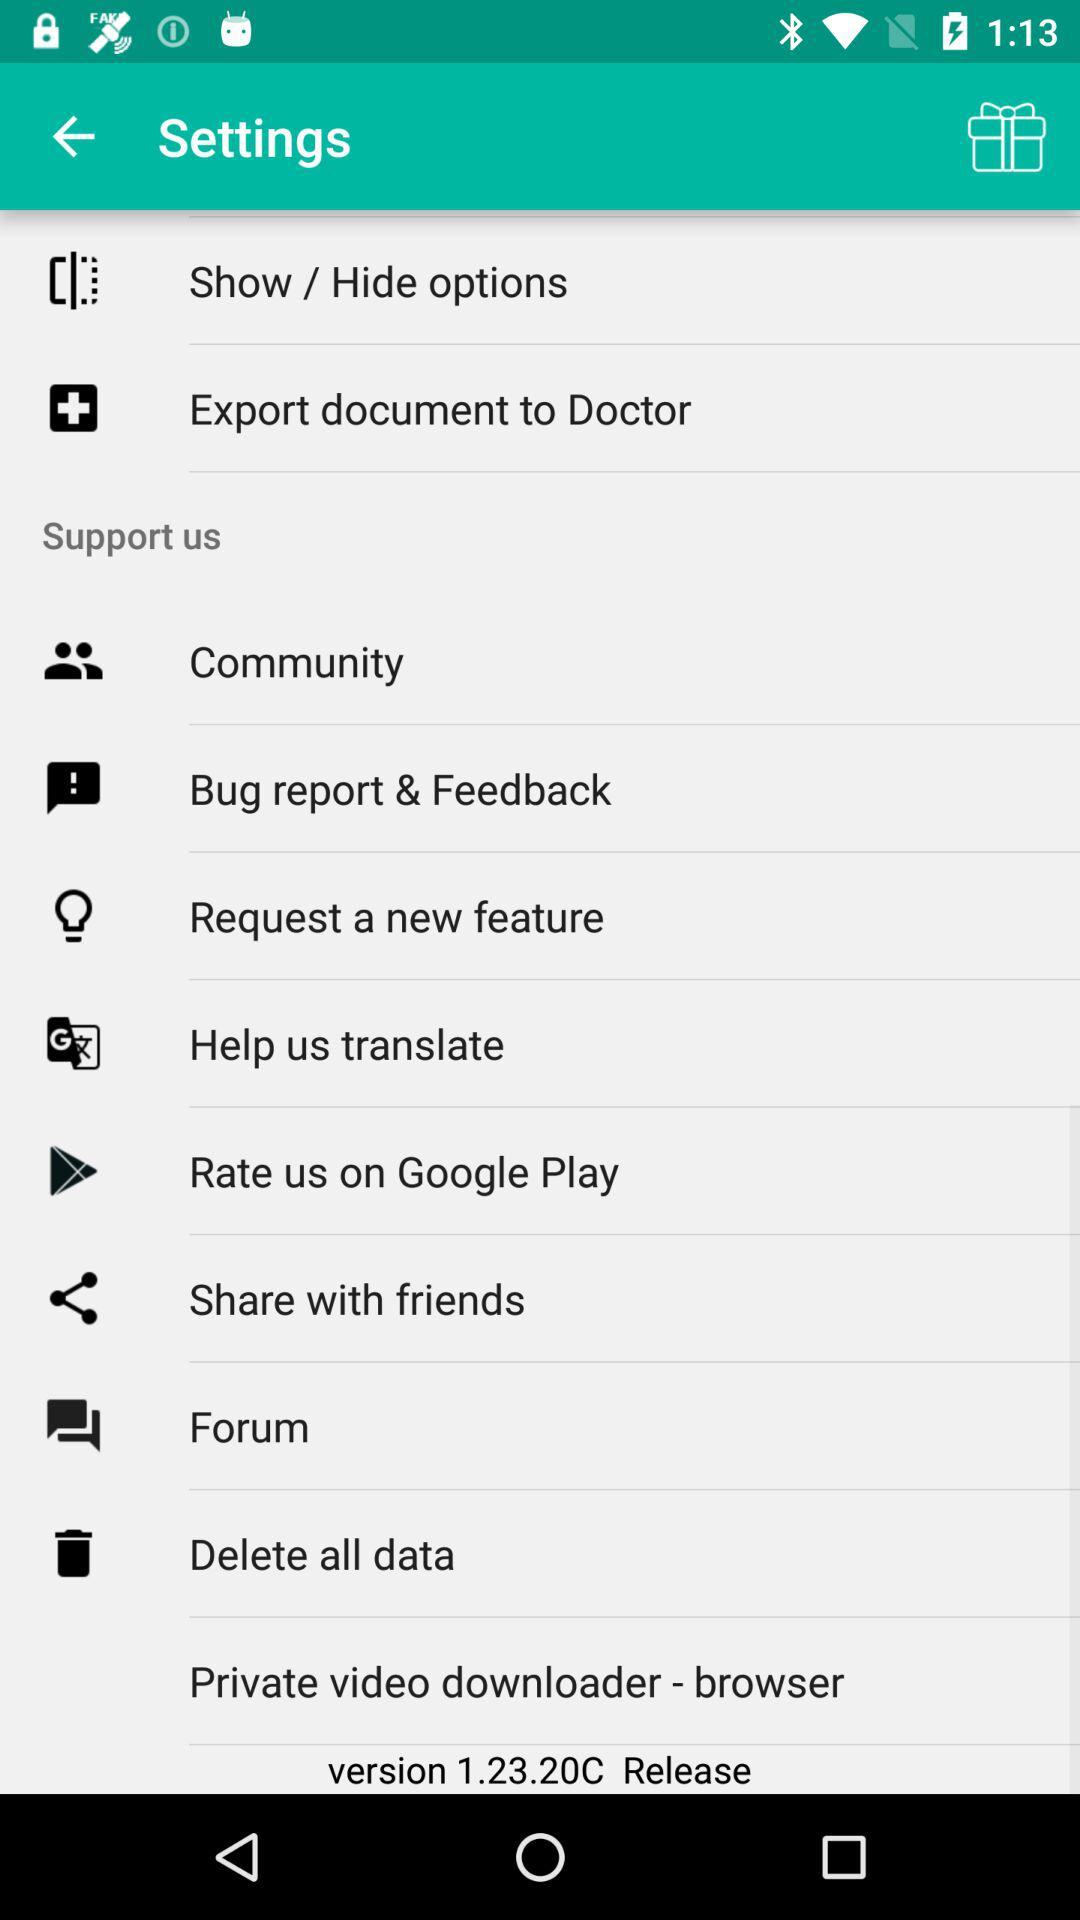Which version of the application is this? The version is 1.23.20C. 